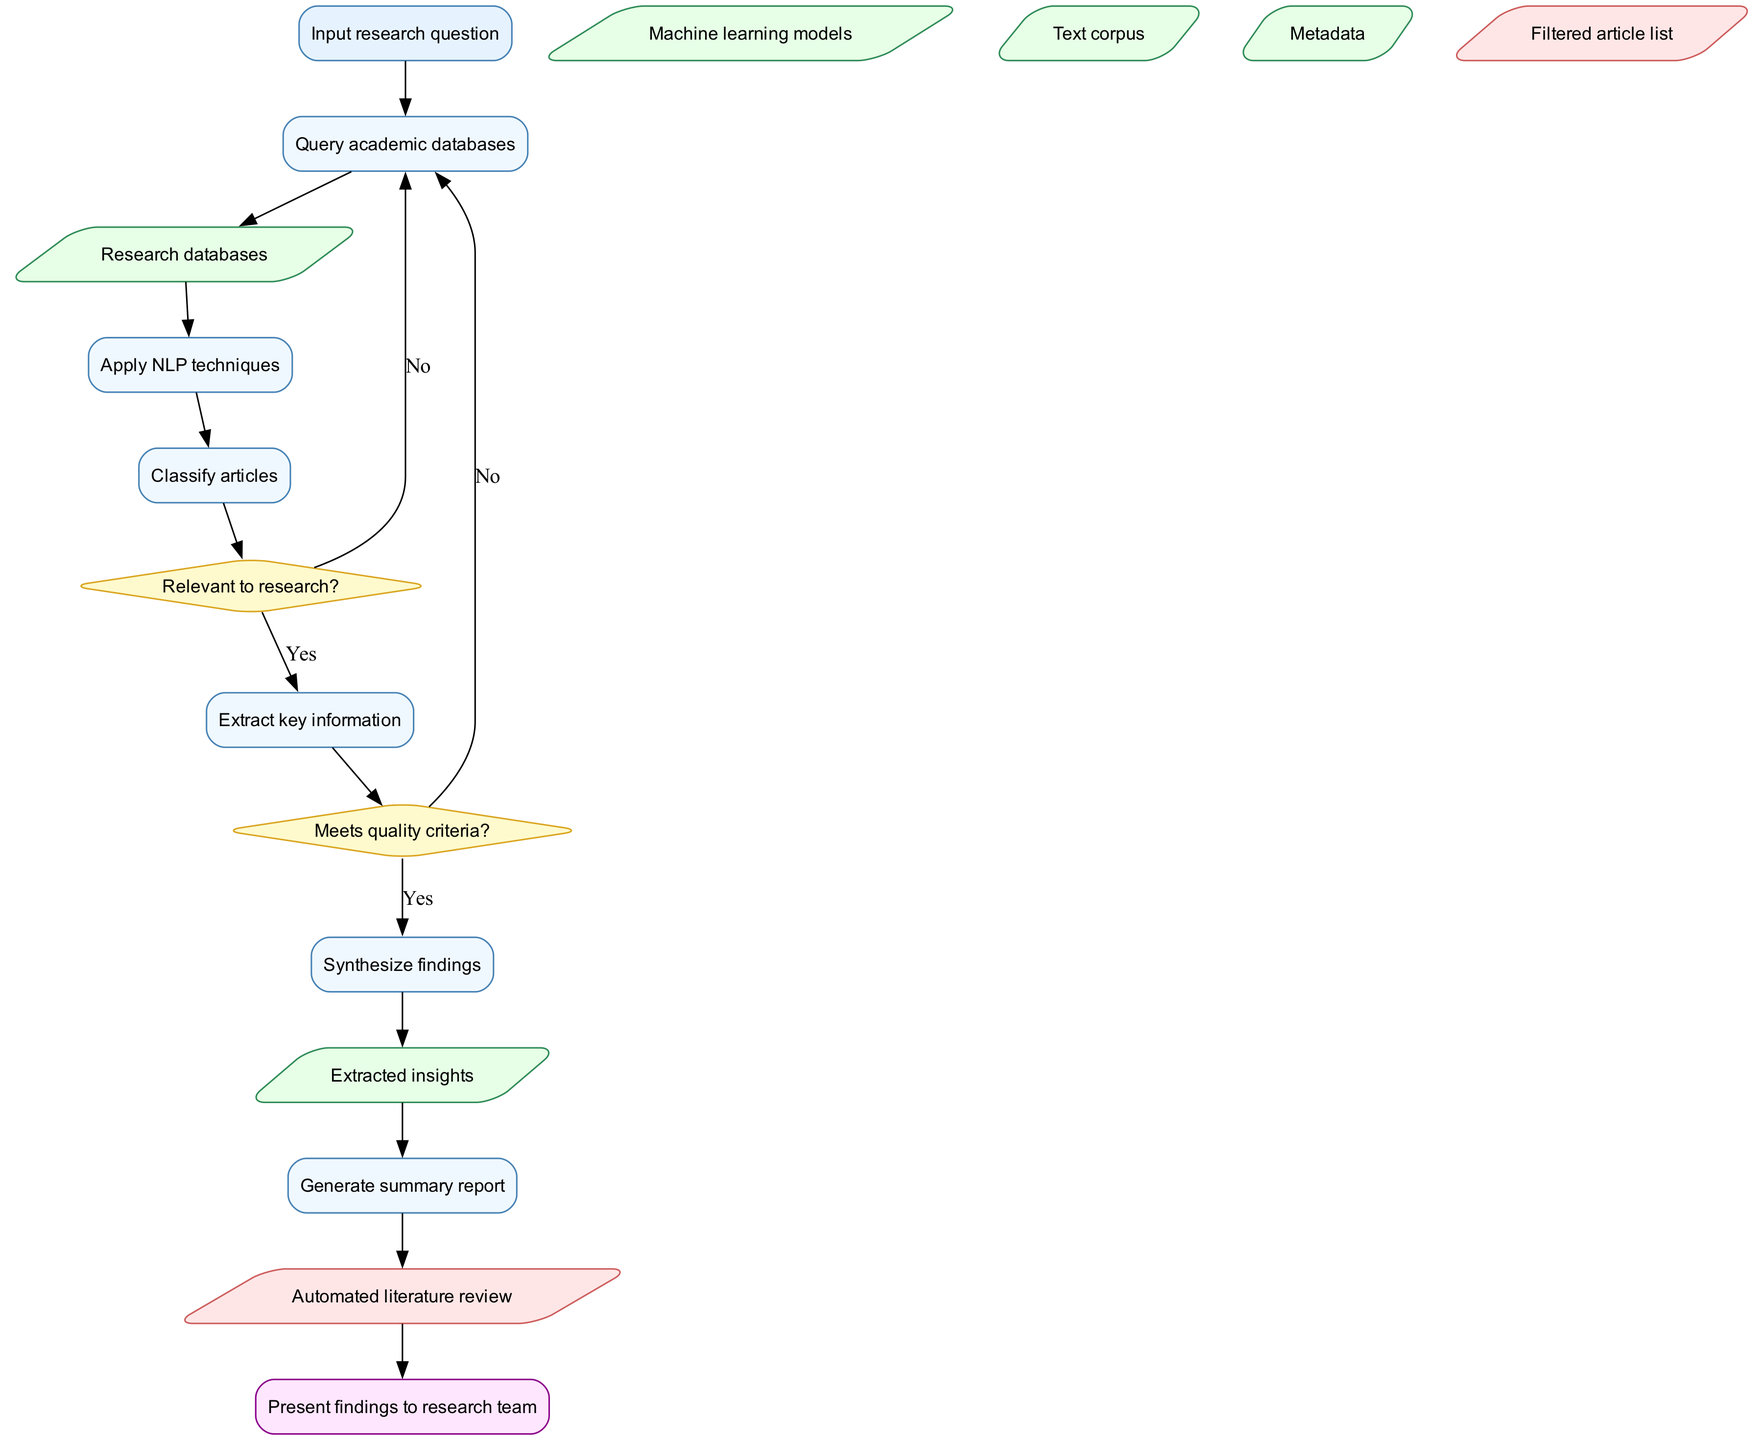What is the first step in the diagram? The diagram starts with the "Input research question" node, indicating the very first action taken in the process.
Answer: Input research question How many processes are there in total? The diagram lists six distinct processes, each represented by a different node. Counting each 'process' node confirms this.
Answer: 6 What decision comes after "Classify articles"? After the "Classify articles" process, the flow leads to the decision node titled "Relevant to research?" which evaluates the outcome of the classification.
Answer: Relevant to research? What are the outputs of the diagram? The diagram specifies two outputs: "Filtered article list" and "Automated literature review," indicating the final deliverables of the process.
Answer: Filtered article list, Automated literature review What happens if an article is not relevant to the research? If the article is determined to be not relevant (the "Relevant to research?" decision is answered with "No"), the flow proceeds back to the "Query academic databases" process to look for other articles.
Answer: Query academic databases Which node represents the final stage of the process? The last node in the flow chart is "Present findings to research team," signifying the conclusion of the automated literature review process.
Answer: Present findings to research team What type of node is used to represent processes? In this flowchart, processes are displayed as rectangular nodes, which are typically used to signify operational steps in flowcharts.
Answer: Rectangle What is evaluated after "Extract key information"? Following the "Extract key information" process, the next step evaluates whether the extracted articles "Meets quality criteria?" as per the decision node connected afterward.
Answer: Meets quality criteria What element is connected to the "Apply NLP techniques" process? The "Apply NLP techniques" process has a direct connection to the "Text corpus," indicating it uses the text data for further analysis.
Answer: Text corpus 